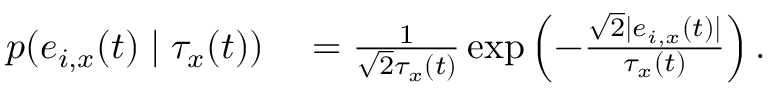<formula> <loc_0><loc_0><loc_500><loc_500>\begin{array} { r l } { p ( e _ { i , x } ( t ) | \tau _ { x } ( t ) ) } & = \frac { 1 } { \sqrt { 2 } \tau _ { x } ( t ) } \exp \left ( - \frac { \sqrt { 2 } | e _ { i , x } ( t ) | } { \tau _ { x } ( t ) } \right ) . } \end{array}</formula> 